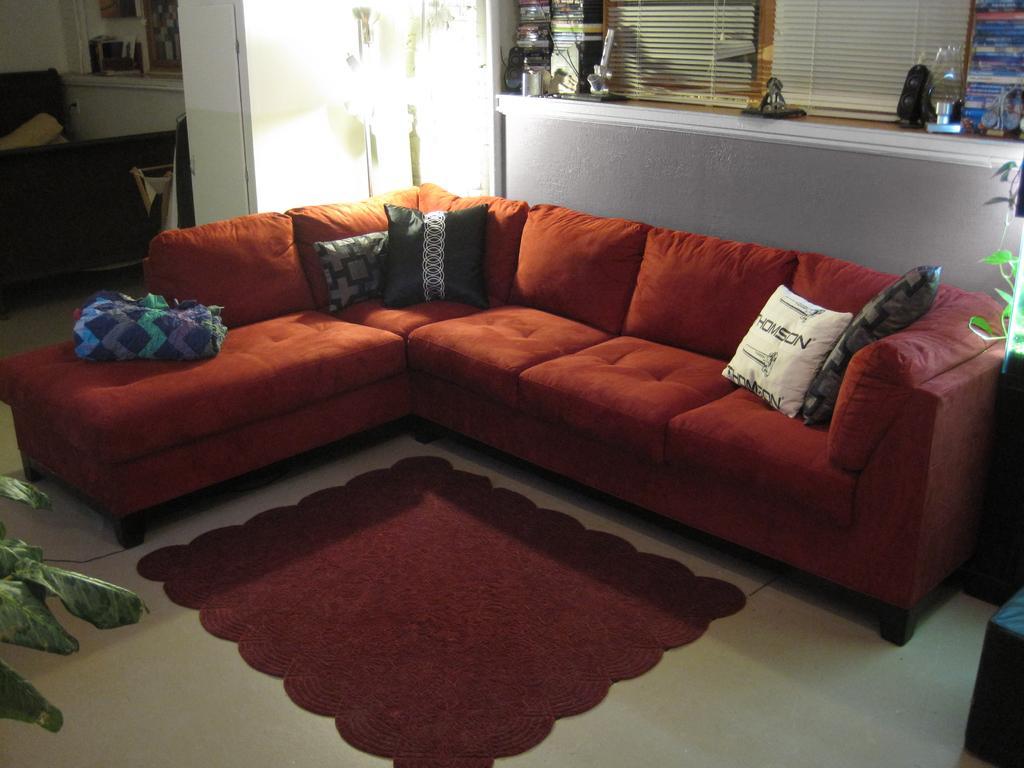Please provide a concise description of this image. In the image we can see a sofa, on the sofa there are pillows. Here we can see a carpet, maroon in color and the carpet is on the floor. We can even see the leaves, cable wire and a door. There are many other things kept on the shelf. 